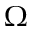Convert formula to latex. <formula><loc_0><loc_0><loc_500><loc_500>\Omega</formula> 